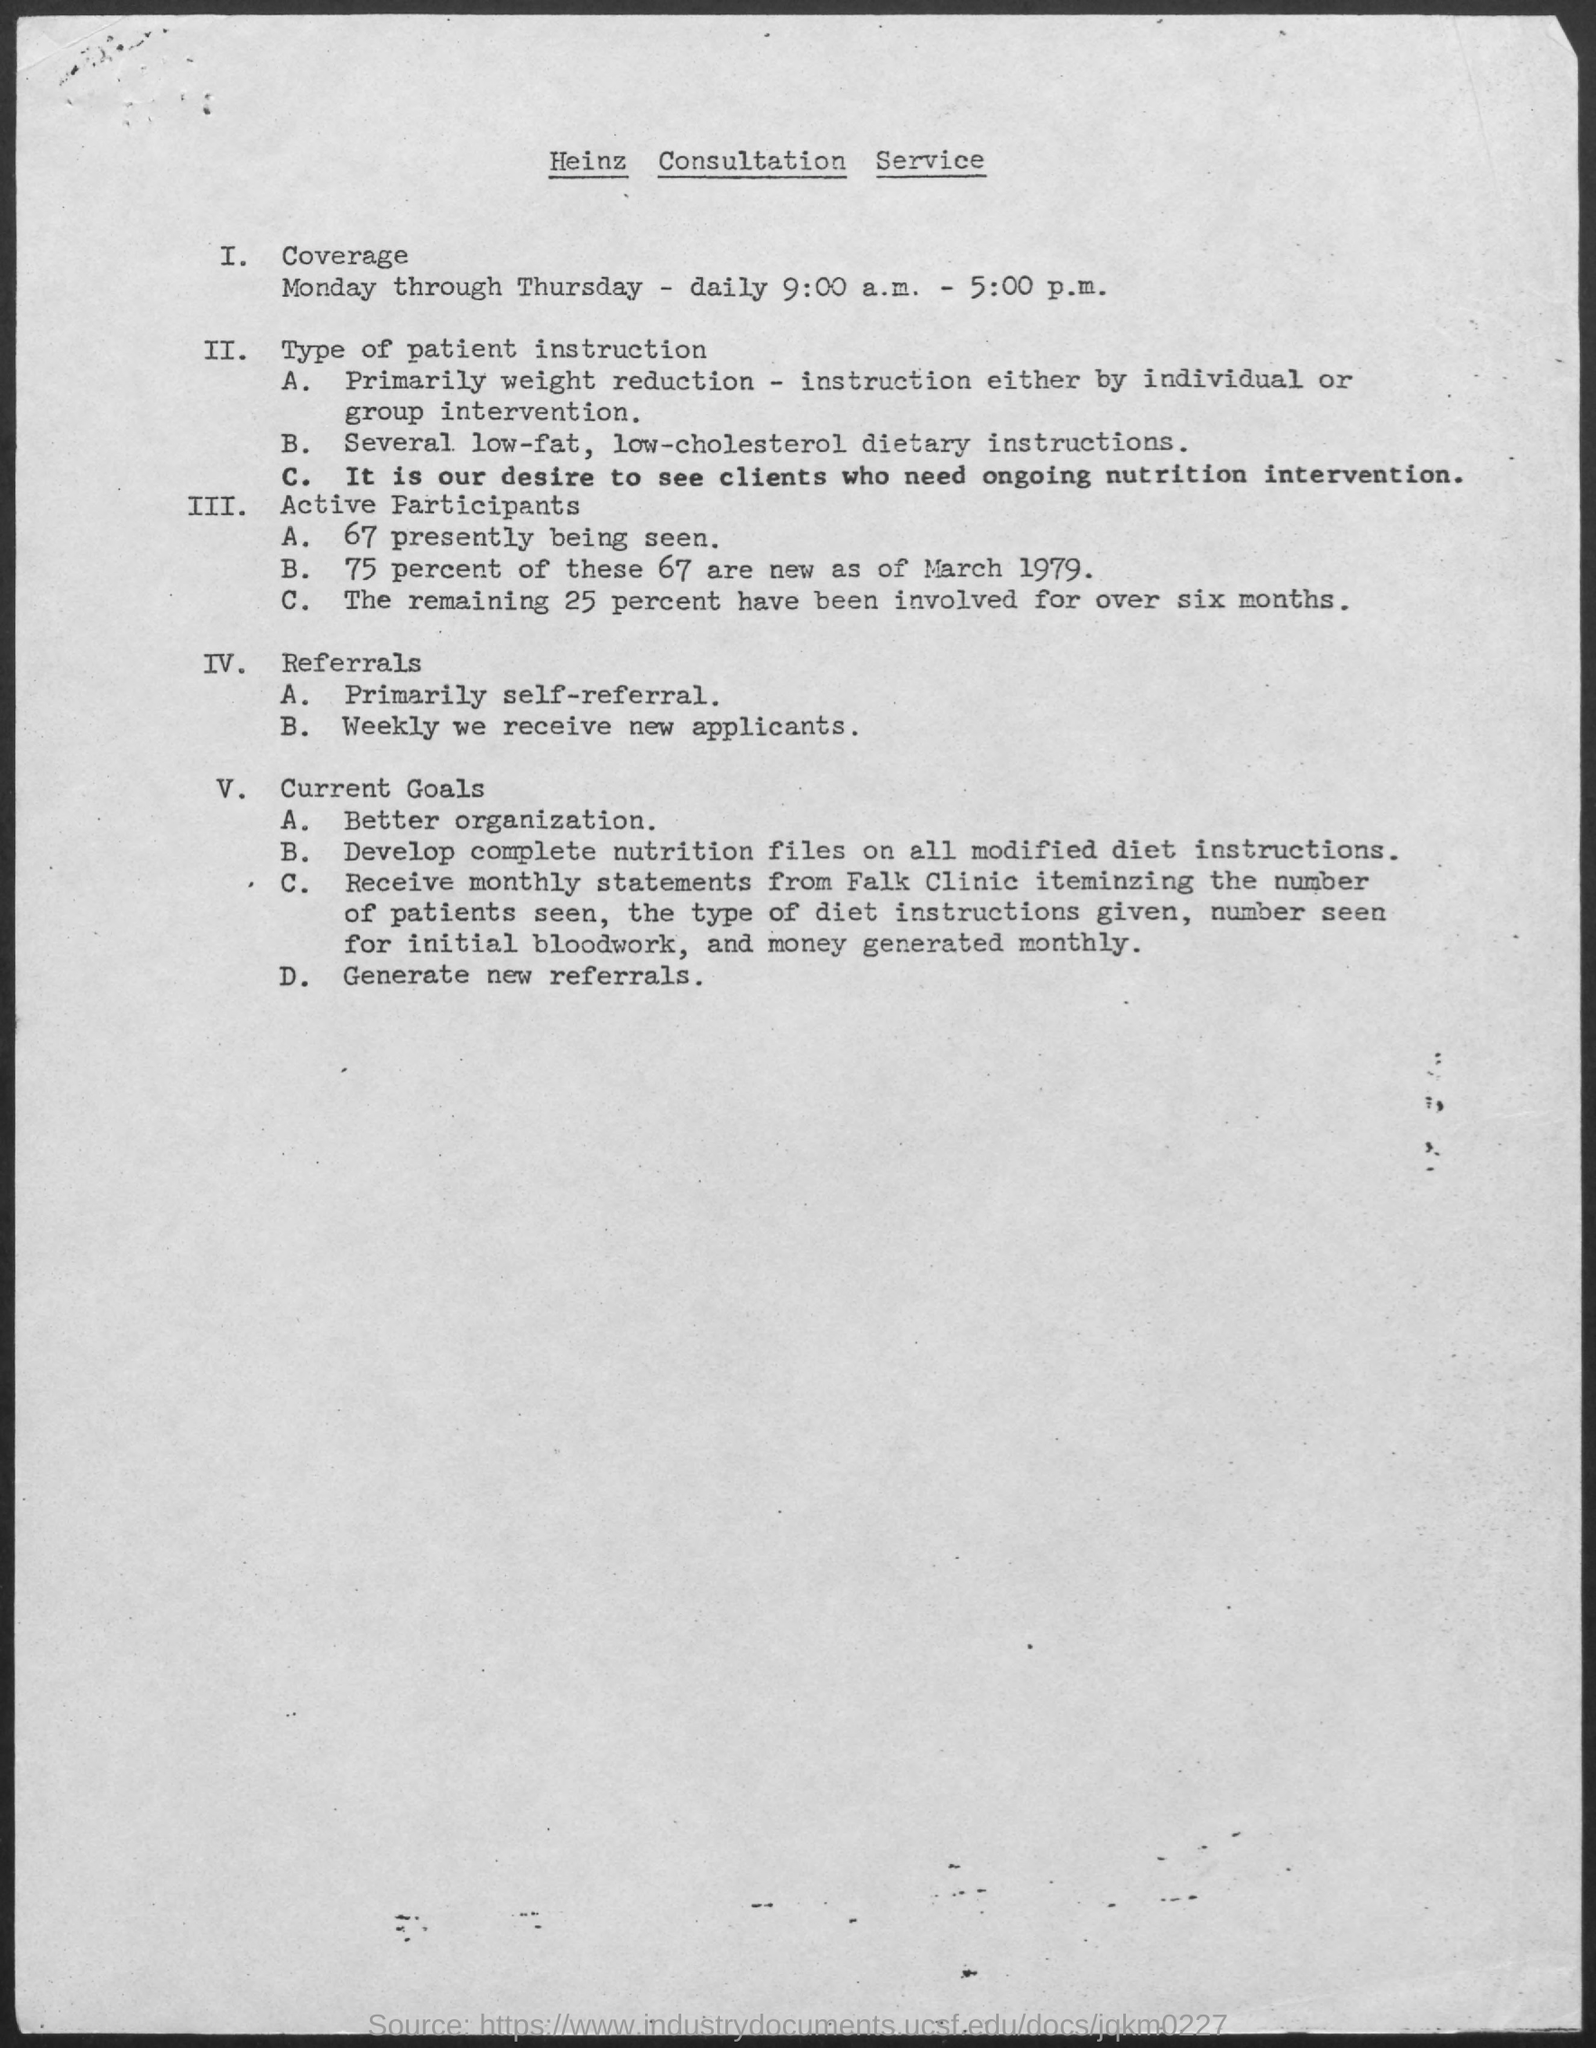Outline some significant characteristics in this image. The document mentions a consultation service named Heinz. 